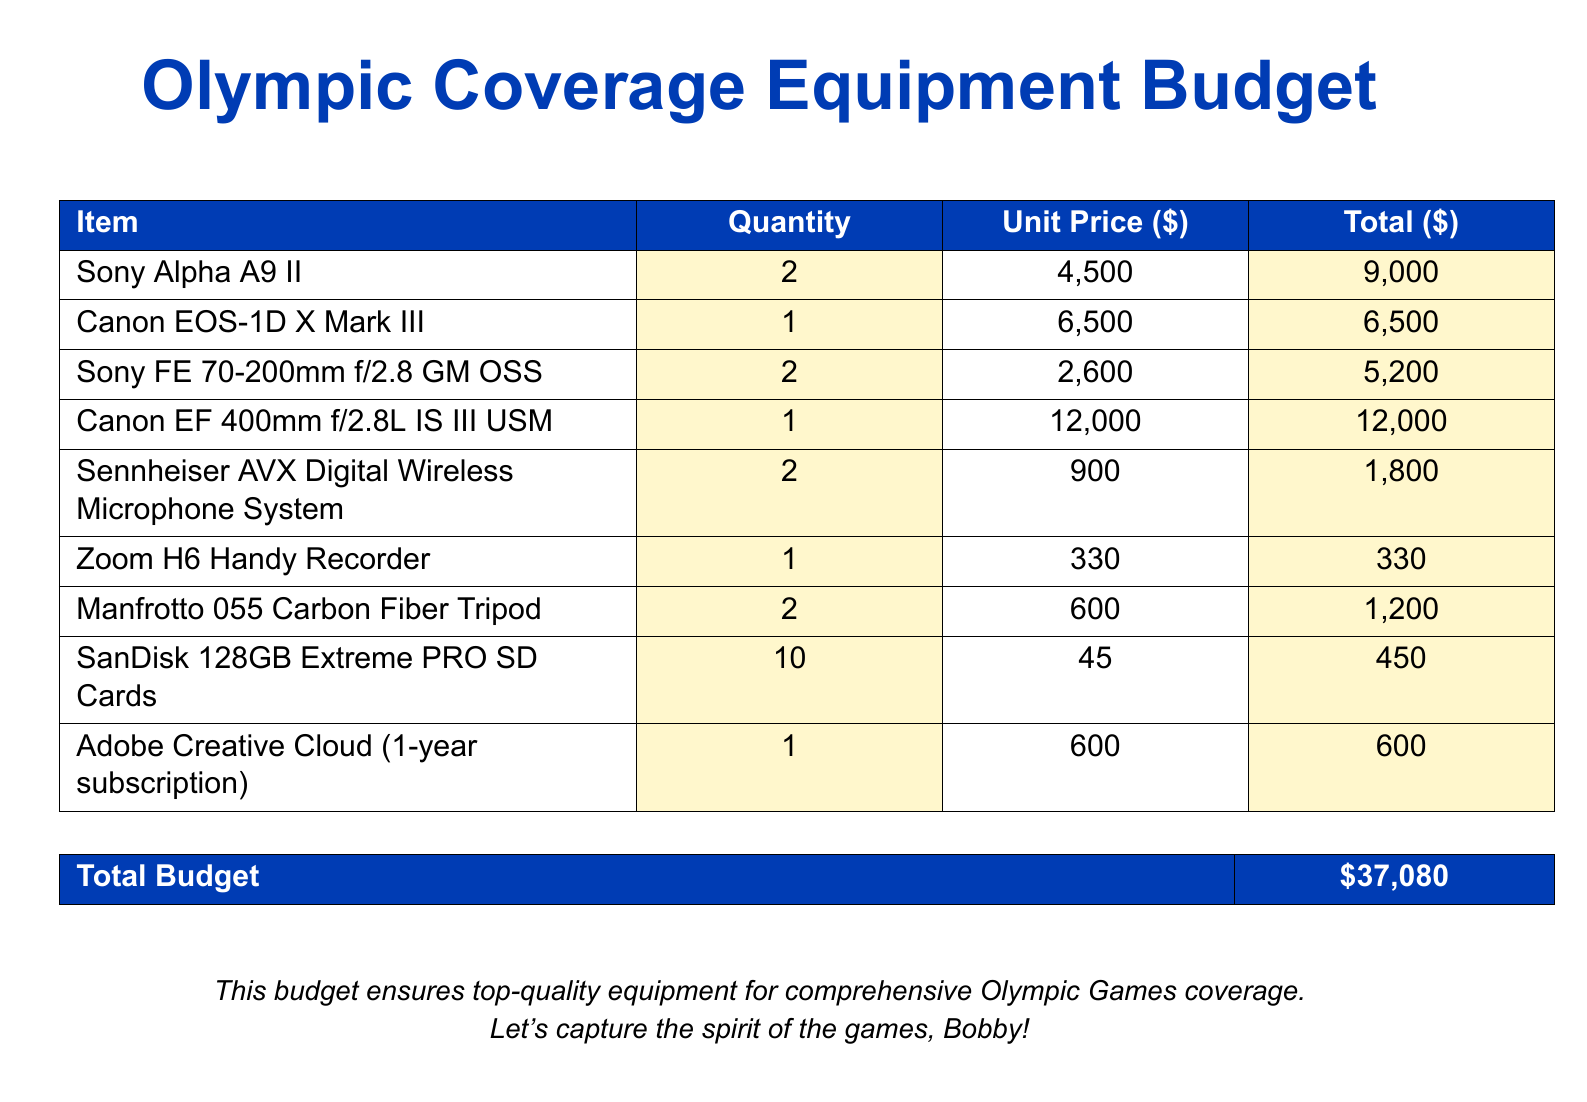what is the total budget? The total budget is stated clearly in the document as the final summary, which is $37,080.
Answer: $37,080 how many Canon EOS-1D X Mark III cameras are listed? The quantity of Canon EOS-1D X Mark III cameras is explicitly mentioned in the equipment list, which shows 1 unit.
Answer: 1 what is the unit price of the Sony Alpha A9 II? The unit price for the Sony Alpha A9 II can be found in the equipment list, set at $4,500.
Answer: $4,500 how many SanDisk 128GB Extreme PRO SD Cards are in the budget? The document specifies that 10 SanDisk 128GB Extreme PRO SD Cards are included in the budget.
Answer: 10 which microphone system is included in the budget? The document names the Sennheiser AVX Digital Wireless Microphone System as the microphone system included in the budget.
Answer: Sennheiser AVX Digital Wireless Microphone System what is the total price for the Canon EF 400mm f/2.8L IS III USM? The total price for the Canon EF 400mm f/2.8L IS III USM can be found in the budget table, which indicates it is $12,000.
Answer: $12,000 how many lenses are listed in the budget? The document presents a total of 3 lenses included in the budget.
Answer: 3 what type of tripod is mentioned in the budget? The budget mentions the Manfrotto 055 Carbon Fiber Tripod as the type of tripod included.
Answer: Manfrotto 055 Carbon Fiber Tripod what software subscription is included in the equipment budget? The document states that an Adobe Creative Cloud (1-year subscription) is part of the equipment budget.
Answer: Adobe Creative Cloud (1-year subscription) 